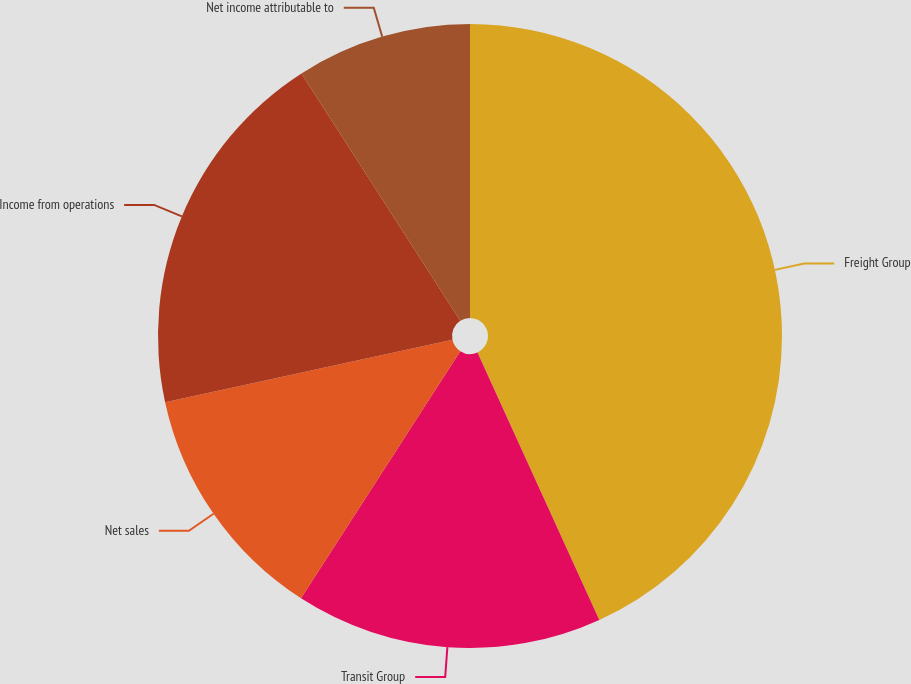Convert chart to OTSL. <chart><loc_0><loc_0><loc_500><loc_500><pie_chart><fcel>Freight Group<fcel>Transit Group<fcel>Net sales<fcel>Income from operations<fcel>Net income attributable to<nl><fcel>43.2%<fcel>15.91%<fcel>12.49%<fcel>19.32%<fcel>9.08%<nl></chart> 